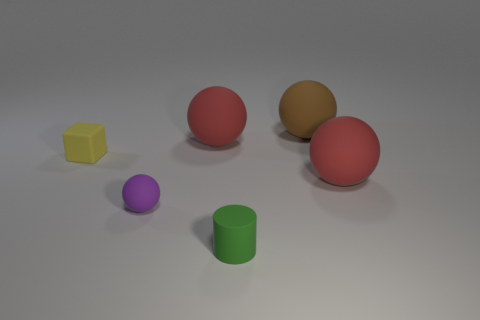Subtract all purple spheres. How many spheres are left? 3 Subtract all cyan balls. Subtract all blue blocks. How many balls are left? 4 Add 3 rubber balls. How many objects exist? 9 Subtract all cylinders. How many objects are left? 5 Subtract 0 gray cylinders. How many objects are left? 6 Subtract all big red rubber objects. Subtract all brown rubber balls. How many objects are left? 3 Add 2 small matte cubes. How many small matte cubes are left? 3 Add 4 small green cylinders. How many small green cylinders exist? 5 